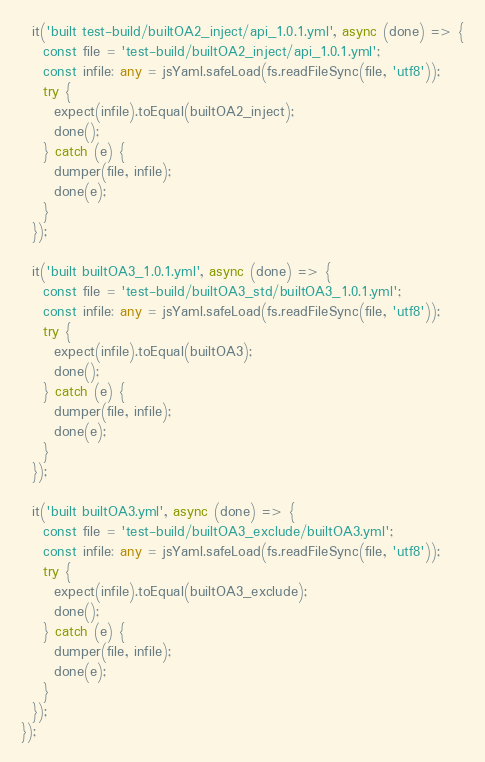<code> <loc_0><loc_0><loc_500><loc_500><_TypeScript_>  it('built test-build/builtOA2_inject/api_1.0.1.yml', async (done) => {
    const file = 'test-build/builtOA2_inject/api_1.0.1.yml';
    const infile: any = jsYaml.safeLoad(fs.readFileSync(file, 'utf8'));
    try {
      expect(infile).toEqual(builtOA2_inject);
      done();
    } catch (e) {
      dumper(file, infile);
      done(e);
    }
  });

  it('built builtOA3_1.0.1.yml', async (done) => {
    const file = 'test-build/builtOA3_std/builtOA3_1.0.1.yml';
    const infile: any = jsYaml.safeLoad(fs.readFileSync(file, 'utf8'));
    try {
      expect(infile).toEqual(builtOA3);
      done();
    } catch (e) {
      dumper(file, infile);
      done(e);
    }
  });

  it('built builtOA3.yml', async (done) => {
    const file = 'test-build/builtOA3_exclude/builtOA3.yml';
    const infile: any = jsYaml.safeLoad(fs.readFileSync(file, 'utf8'));
    try {
      expect(infile).toEqual(builtOA3_exclude);
      done();
    } catch (e) {
      dumper(file, infile);
      done(e);
    }
  });
});
</code> 